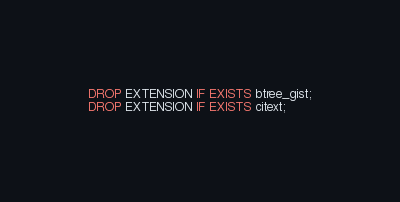Convert code to text. <code><loc_0><loc_0><loc_500><loc_500><_SQL_>DROP EXTENSION IF EXISTS btree_gist;
DROP EXTENSION IF EXISTS citext;
</code> 